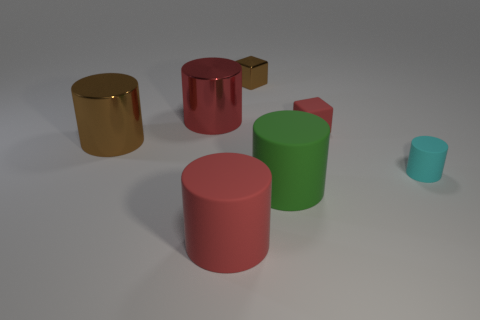Subtract all brown shiny cylinders. How many cylinders are left? 4 Subtract all blocks. How many objects are left? 5 Subtract 1 blocks. How many blocks are left? 1 Add 2 green cylinders. How many objects exist? 9 Subtract all green cylinders. How many cylinders are left? 4 Subtract all gray cylinders. Subtract all purple balls. How many cylinders are left? 5 Subtract all green cylinders. How many cyan blocks are left? 0 Subtract all purple blocks. Subtract all red matte cylinders. How many objects are left? 6 Add 7 big brown cylinders. How many big brown cylinders are left? 8 Add 1 big brown metal things. How many big brown metal things exist? 2 